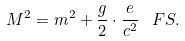<formula> <loc_0><loc_0><loc_500><loc_500>M ^ { 2 } = m ^ { 2 } + \frac { g } { 2 } \cdot \frac { e } { c ^ { 2 } } \, \ F S .</formula> 